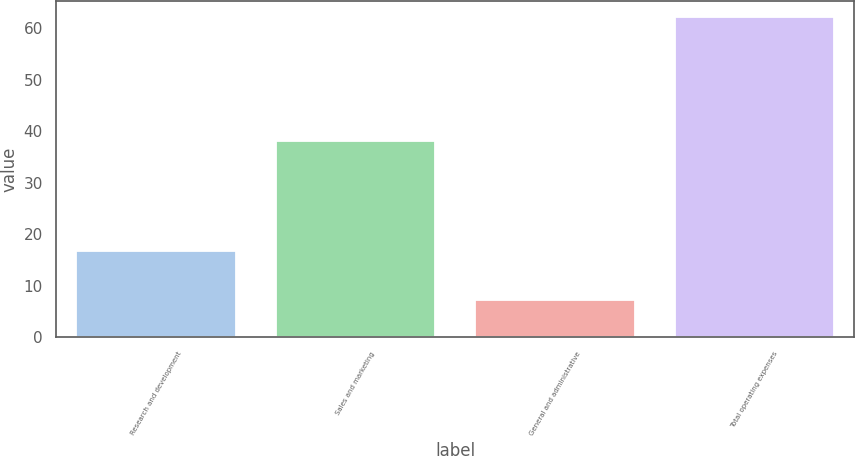<chart> <loc_0><loc_0><loc_500><loc_500><bar_chart><fcel>Research and development<fcel>Sales and marketing<fcel>General and administrative<fcel>Total operating expenses<nl><fcel>16.7<fcel>38.2<fcel>7.3<fcel>62.2<nl></chart> 